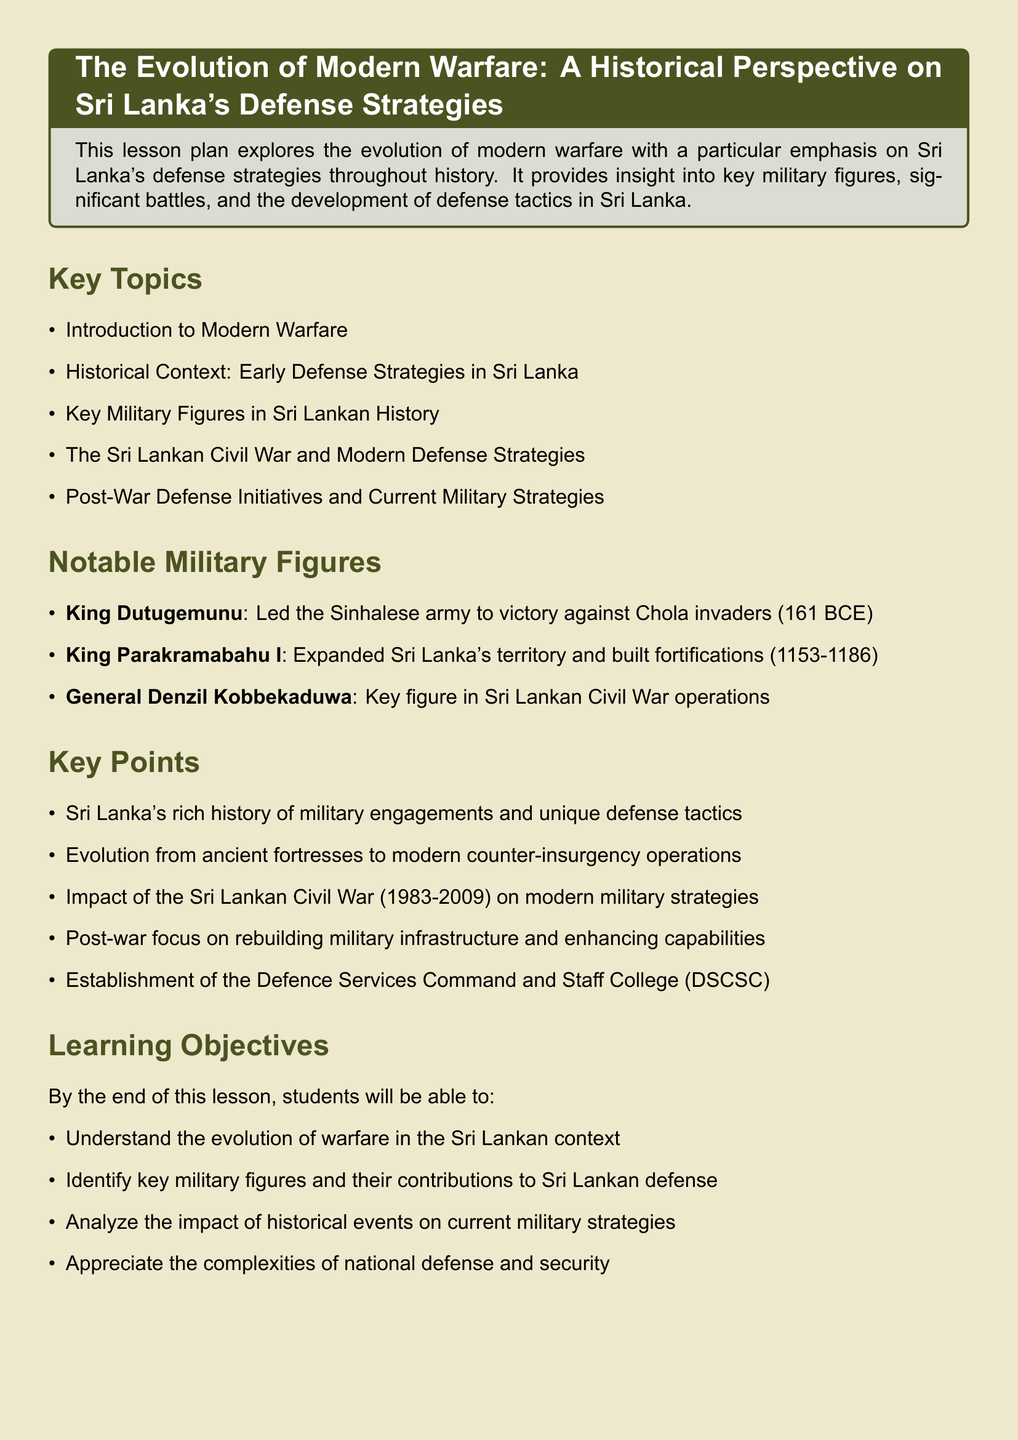What is the title of the lesson plan? The title of the lesson plan is found in the title section of the document.
Answer: The Evolution of Modern Warfare: A Historical Perspective on Sri Lanka's Defense Strategies Who was a key figure in operations during the Sri Lankan Civil War? The document provides information about notable military figures, including General Denzil Kobbekaduwa's role in the Civil War.
Answer: General Denzil Kobbekaduwa What did King Dutugemunu lead his army to victory against? The document states that King Dutugemunu led the Sinhalese army against Chola invaders.
Answer: Chola invaders In what years did King Parakramabahu I rule? The document lists the years of King Parakramabahu I's reign under notable military figures.
Answer: 1153-1186 What is one learning objective of the lesson? The learning objectives are outlined in a specific section of the document, one being understanding the evolution of warfare.
Answer: Understand the evolution of warfare in the Sri Lankan context What documentary is recommended as a resource? The recommended resources include a documentary mentioned in the list of references.
Answer: Sri Lanka: Art of War What does DSCSC stand for? The document refers to the establishment of the Defence Services Command and Staff College, which is abbreviated to DSCSC.
Answer: Defence Services Command and Staff College How long did the Sri Lankan Civil War last? The duration of the Sri Lankan Civil War is mentioned in the key points section of the document.
Answer: 1983-2009 